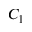<formula> <loc_0><loc_0><loc_500><loc_500>C _ { 1 }</formula> 